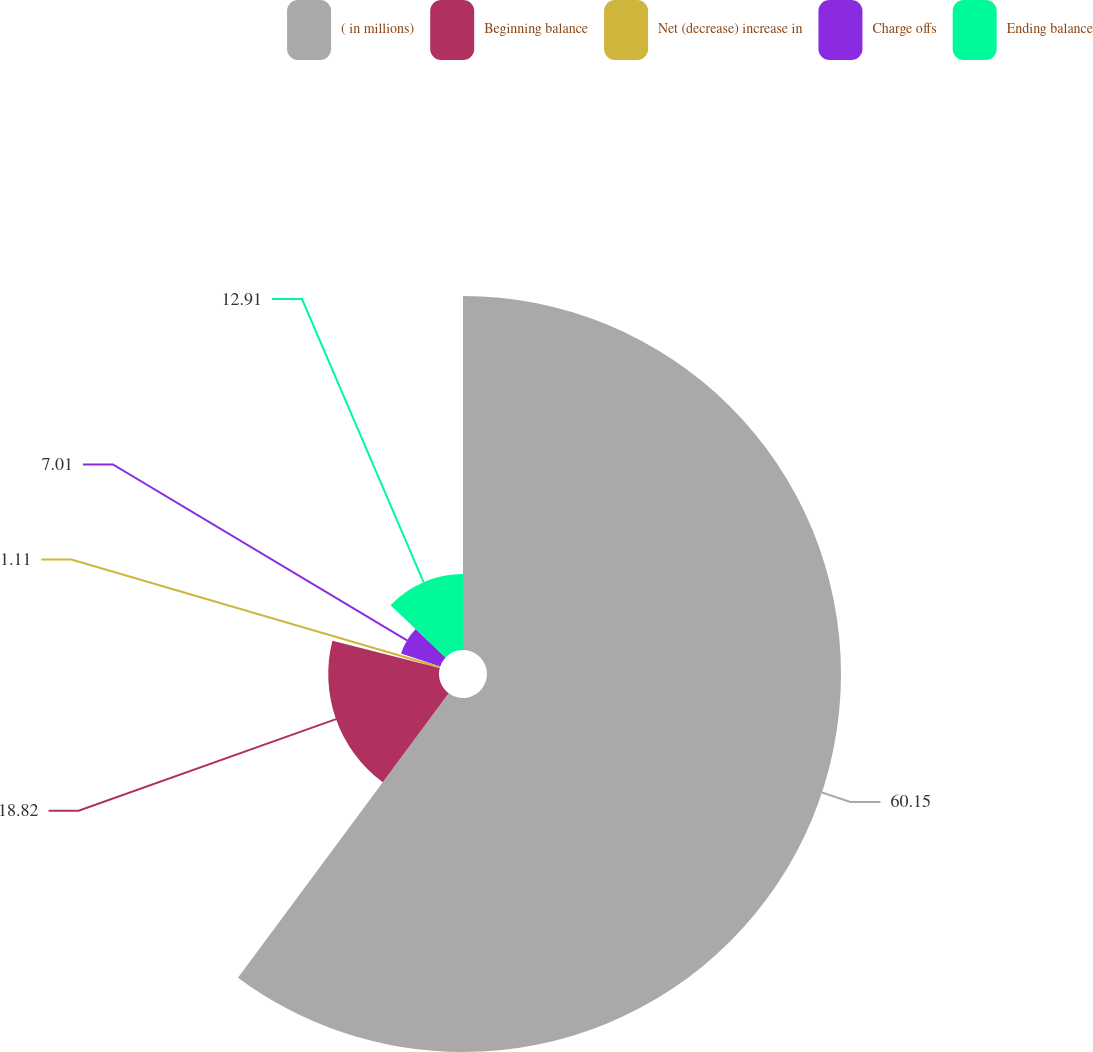<chart> <loc_0><loc_0><loc_500><loc_500><pie_chart><fcel>( in millions)<fcel>Beginning balance<fcel>Net (decrease) increase in<fcel>Charge offs<fcel>Ending balance<nl><fcel>60.15%<fcel>18.82%<fcel>1.11%<fcel>7.01%<fcel>12.91%<nl></chart> 